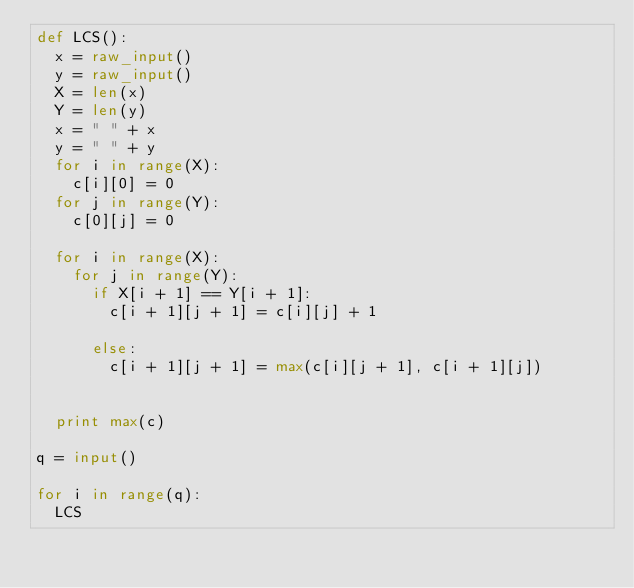<code> <loc_0><loc_0><loc_500><loc_500><_Python_>def LCS():
  x = raw_input()
  y = raw_input()
  X = len(x)
  Y = len(y)
  x = " " + x
  y = " " + y
  for i in range(X):
    c[i][0] = 0
  for j in range(Y):
    c[0][j] = 0

  for i in range(X):
    for j in range(Y):
      if X[i + 1] == Y[i + 1]: 
        c[i + 1][j + 1] = c[i][j] + 1

      else:
        c[i + 1][j + 1] = max(c[i][j + 1], c[i + 1][j])
        

  print max(c)

q = input()

for i in range(q):
  LCS

  
    </code> 